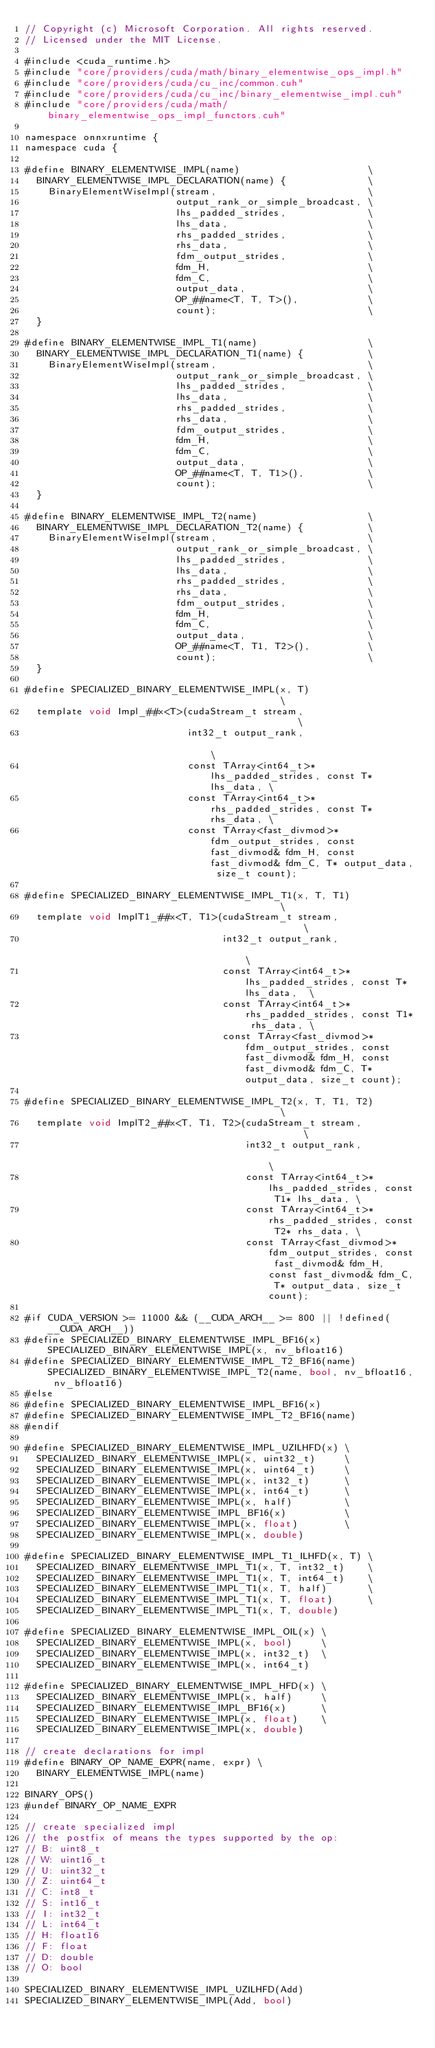Convert code to text. <code><loc_0><loc_0><loc_500><loc_500><_Cuda_>// Copyright (c) Microsoft Corporation. All rights reserved.
// Licensed under the MIT License.

#include <cuda_runtime.h>
#include "core/providers/cuda/math/binary_elementwise_ops_impl.h"
#include "core/providers/cuda/cu_inc/common.cuh"
#include "core/providers/cuda/cu_inc/binary_elementwise_impl.cuh"
#include "core/providers/cuda/math/binary_elementwise_ops_impl_functors.cuh"

namespace onnxruntime {
namespace cuda {

#define BINARY_ELEMENTWISE_IMPL(name)                      \
  BINARY_ELEMENTWISE_IMPL_DECLARATION(name) {              \
    BinaryElementWiseImpl(stream,                          \
                          output_rank_or_simple_broadcast, \
                          lhs_padded_strides,              \
                          lhs_data,                        \
                          rhs_padded_strides,              \
                          rhs_data,                        \
                          fdm_output_strides,              \
                          fdm_H,                           \
                          fdm_C,                           \
                          output_data,                     \
                          OP_##name<T, T, T>(),            \
                          count);                          \
  }

#define BINARY_ELEMENTWISE_IMPL_T1(name)                   \
  BINARY_ELEMENTWISE_IMPL_DECLARATION_T1(name) {           \
    BinaryElementWiseImpl(stream,                          \
                          output_rank_or_simple_broadcast, \
                          lhs_padded_strides,              \
                          lhs_data,                        \
                          rhs_padded_strides,              \
                          rhs_data,                        \
                          fdm_output_strides,              \
                          fdm_H,                           \
                          fdm_C,                           \
                          output_data,                     \
                          OP_##name<T, T, T1>(),           \
                          count);                          \
  }

#define BINARY_ELEMENTWISE_IMPL_T2(name)                   \
  BINARY_ELEMENTWISE_IMPL_DECLARATION_T2(name) {           \
    BinaryElementWiseImpl(stream,                          \
                          output_rank_or_simple_broadcast, \
                          lhs_padded_strides,              \
                          lhs_data,                        \
                          rhs_padded_strides,              \
                          rhs_data,                        \
                          fdm_output_strides,              \
                          fdm_H,                           \
                          fdm_C,                           \
                          output_data,                     \
                          OP_##name<T, T1, T2>(),          \
                          count);                          \
  }

#define SPECIALIZED_BINARY_ELEMENTWISE_IMPL(x, T)                                         \
  template void Impl_##x<T>(cudaStream_t stream,                                          \
                            int32_t output_rank,                                          \
                            const TArray<int64_t>* lhs_padded_strides, const T* lhs_data, \
                            const TArray<int64_t>* rhs_padded_strides, const T* rhs_data, \
                            const TArray<fast_divmod>* fdm_output_strides, const fast_divmod& fdm_H, const fast_divmod& fdm_C, T* output_data, size_t count);

#define SPECIALIZED_BINARY_ELEMENTWISE_IMPL_T1(x, T, T1)                                         \
  template void ImplT1_##x<T, T1>(cudaStream_t stream,                                           \
                                  int32_t output_rank,                                           \
                                  const TArray<int64_t>* lhs_padded_strides, const T* lhs_data,  \
                                  const TArray<int64_t>* rhs_padded_strides, const T1* rhs_data, \
                                  const TArray<fast_divmod>* fdm_output_strides, const fast_divmod& fdm_H, const fast_divmod& fdm_C, T* output_data, size_t count);

#define SPECIALIZED_BINARY_ELEMENTWISE_IMPL_T2(x, T, T1, T2)                                         \
  template void ImplT2_##x<T, T1, T2>(cudaStream_t stream,                                           \
                                      int32_t output_rank,                                           \
                                      const TArray<int64_t>* lhs_padded_strides, const T1* lhs_data, \
                                      const TArray<int64_t>* rhs_padded_strides, const T2* rhs_data, \
                                      const TArray<fast_divmod>* fdm_output_strides, const fast_divmod& fdm_H, const fast_divmod& fdm_C, T* output_data, size_t count);

#if CUDA_VERSION >= 11000 && (__CUDA_ARCH__ >= 800 || !defined(__CUDA_ARCH__))
#define SPECIALIZED_BINARY_ELEMENTWISE_IMPL_BF16(x) SPECIALIZED_BINARY_ELEMENTWISE_IMPL(x, nv_bfloat16)
#define SPECIALIZED_BINARY_ELEMENTWISE_IMPL_T2_BF16(name) SPECIALIZED_BINARY_ELEMENTWISE_IMPL_T2(name, bool, nv_bfloat16, nv_bfloat16)
#else
#define SPECIALIZED_BINARY_ELEMENTWISE_IMPL_BF16(x)
#define SPECIALIZED_BINARY_ELEMENTWISE_IMPL_T2_BF16(name)
#endif

#define SPECIALIZED_BINARY_ELEMENTWISE_IMPL_UZILHFD(x) \
  SPECIALIZED_BINARY_ELEMENTWISE_IMPL(x, uint32_t)     \
  SPECIALIZED_BINARY_ELEMENTWISE_IMPL(x, uint64_t)     \
  SPECIALIZED_BINARY_ELEMENTWISE_IMPL(x, int32_t)      \
  SPECIALIZED_BINARY_ELEMENTWISE_IMPL(x, int64_t)      \
  SPECIALIZED_BINARY_ELEMENTWISE_IMPL(x, half)         \
  SPECIALIZED_BINARY_ELEMENTWISE_IMPL_BF16(x)          \
  SPECIALIZED_BINARY_ELEMENTWISE_IMPL(x, float)        \
  SPECIALIZED_BINARY_ELEMENTWISE_IMPL(x, double)

#define SPECIALIZED_BINARY_ELEMENTWISE_IMPL_T1_ILHFD(x, T) \
  SPECIALIZED_BINARY_ELEMENTWISE_IMPL_T1(x, T, int32_t)    \
  SPECIALIZED_BINARY_ELEMENTWISE_IMPL_T1(x, T, int64_t)    \
  SPECIALIZED_BINARY_ELEMENTWISE_IMPL_T1(x, T, half)       \
  SPECIALIZED_BINARY_ELEMENTWISE_IMPL_T1(x, T, float)      \
  SPECIALIZED_BINARY_ELEMENTWISE_IMPL_T1(x, T, double)

#define SPECIALIZED_BINARY_ELEMENTWISE_IMPL_OIL(x) \
  SPECIALIZED_BINARY_ELEMENTWISE_IMPL(x, bool)     \
  SPECIALIZED_BINARY_ELEMENTWISE_IMPL(x, int32_t)  \
  SPECIALIZED_BINARY_ELEMENTWISE_IMPL(x, int64_t)

#define SPECIALIZED_BINARY_ELEMENTWISE_IMPL_HFD(x) \
  SPECIALIZED_BINARY_ELEMENTWISE_IMPL(x, half)     \
  SPECIALIZED_BINARY_ELEMENTWISE_IMPL_BF16(x)      \
  SPECIALIZED_BINARY_ELEMENTWISE_IMPL(x, float)    \
  SPECIALIZED_BINARY_ELEMENTWISE_IMPL(x, double)

// create declarations for impl
#define BINARY_OP_NAME_EXPR(name, expr) \
  BINARY_ELEMENTWISE_IMPL(name)

BINARY_OPS()
#undef BINARY_OP_NAME_EXPR

// create specialized impl
// the postfix of means the types supported by the op:
// B: uint8_t
// W: uint16_t
// U: uint32_t
// Z: uint64_t
// C: int8_t
// S: int16_t
// I: int32_t
// L: int64_t
// H: float16
// F: float
// D: double
// O: bool

SPECIALIZED_BINARY_ELEMENTWISE_IMPL_UZILHFD(Add)
SPECIALIZED_BINARY_ELEMENTWISE_IMPL(Add, bool)</code> 